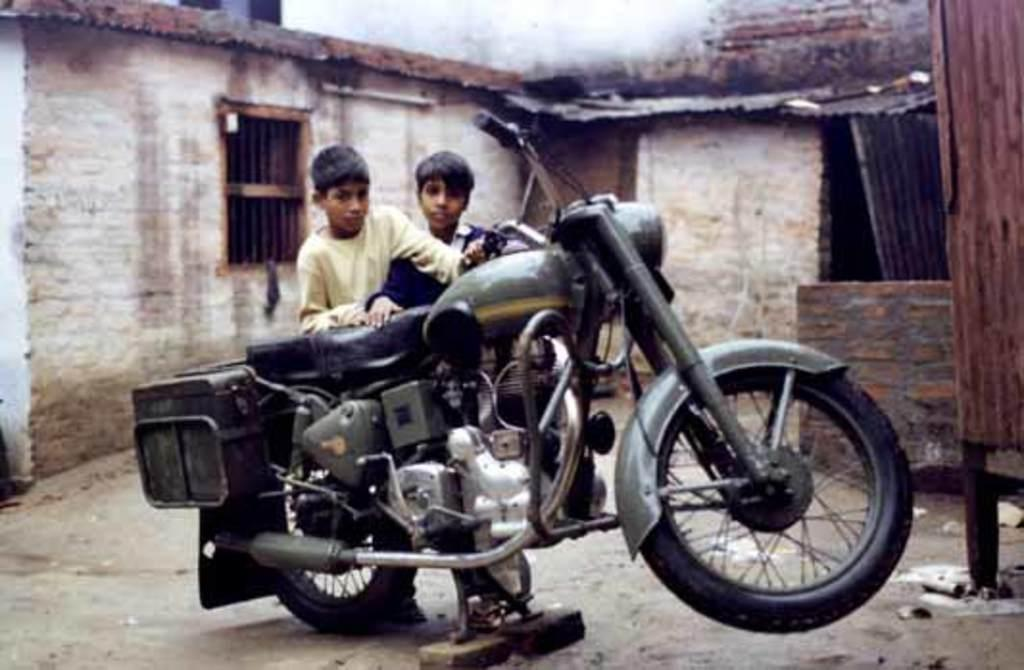What is the main subject in the center of the image? There is a bike in the center of the image. How many kids are present in the image? Two kids are standing in the image. What can be seen in the background of the image? There is a wall, a window, and a few other objects in the background of the image. What direction is the bike facing in the image? The direction the bike is facing cannot be determined from the image alone. How much dust is present on the bike in the image? There is no indication of dust on the bike in the image. 